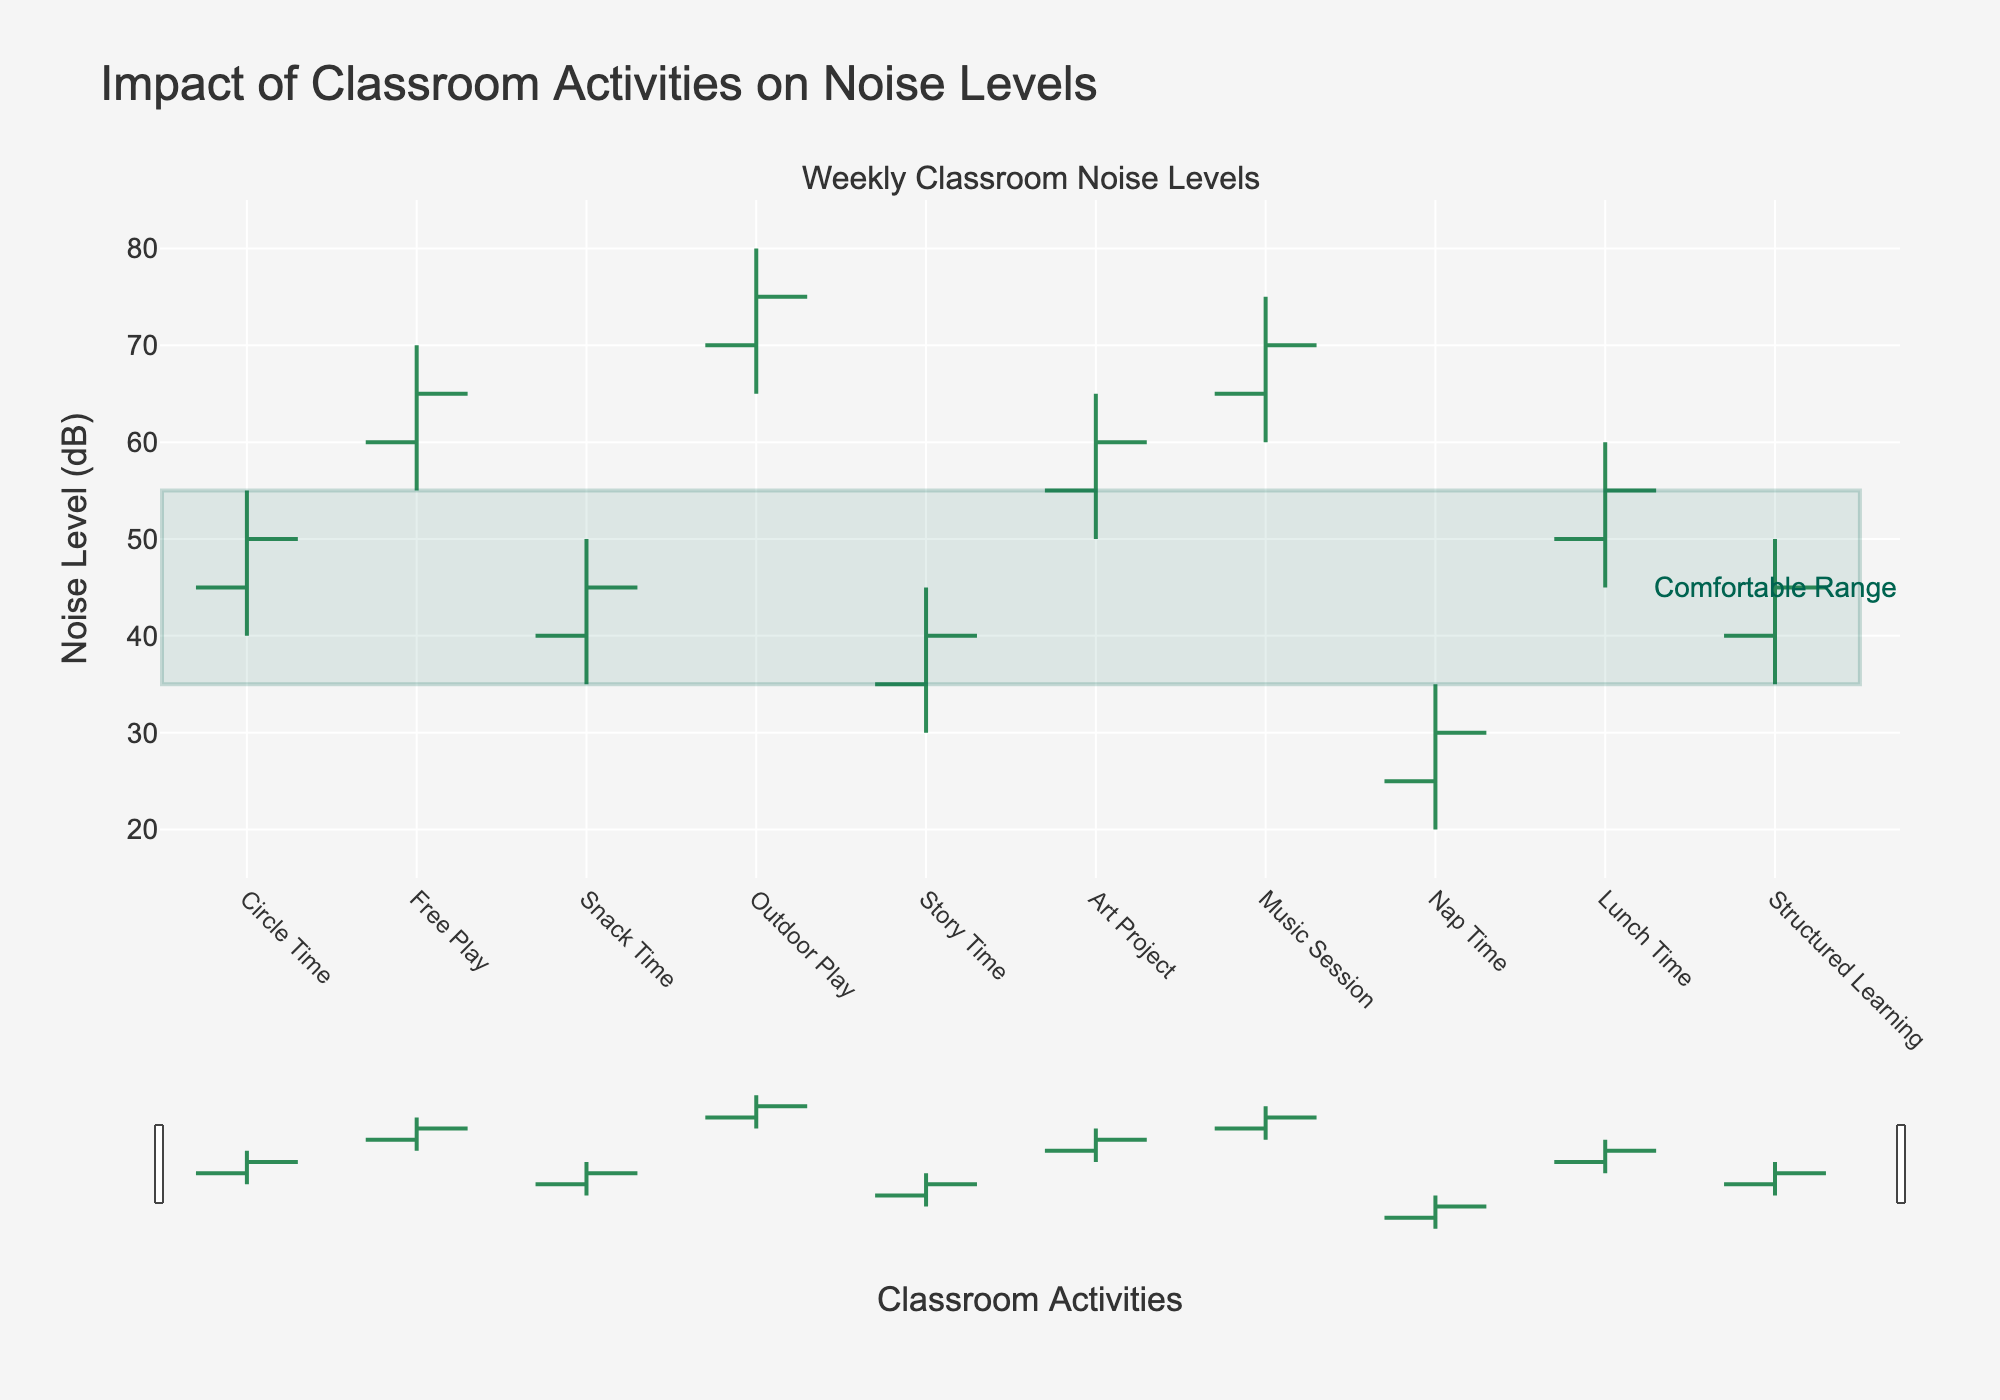What's the range of noise levels during Nap Time? The range is the difference between the highest and lowest values. For Nap Time, the highest noise level is 35 dB and the lowest is 20 dB. So, the range is 35 - 20 = 15 dB.
Answer: 15 dB Which activity has the highest closing noise level? The closing noise level is represented by the 'Close' value. For each activity, compare the closing values. Outdoor Play has the highest closing noise level of 75 dB.
Answer: Outdoor Play How often is the noise level above the comfortable range during Free Play? The comfortable noise range is highlighted between 35 dB and 55 dB. During Free Play, the noise levels (55 dB to 70 dB) are always above this range.
Answer: Always What is the average closing noise level of Story Time and Snack Time combined? The closing noise levels for Story Time and Snack Time are 40 dB and 45 dB respectively. The average is calculated as (40 + 45) / 2 = 42.5 dB.
Answer: 42.5 dB Which activity has the narrowest range of noise levels? The range is calculated by subtracting the lowest value from the highest. For each activity: Circle Time (15), Free Play (15), Snack Time (15), Outdoor Play (15), Story Time (15), Art Project (15), Music Session (15), Nap Time (15), Lunch Time (15), Structured Learning (15). All activities have the same range.
Answer: All activities have the same range How does structured learning's maximum noise level compare to the comfortable range? Structured Learning has a maximum noise level of 50 dB, which is within the comfortable range of 35-55 dB.
Answer: Within range Which activities have both their open and close noise levels within the comfortable range? Circle Time (45-50), Snack Time (40-45), Story Time (35-40), Structured Learning (40-45). All open and close values for these activities fall within the 35-55 dB range.
Answer: Circle Time, Snack Time, Story Time, Structured Learning Which activity shows the greatest increase in noise level from opening to closing? Subtract the open value from the close value for each activity, and find the maximum: Circle Time (50-45=5), Free Play (65-60=5), Snack Time (45-40=5), Outdoor Play (75-70=5), Story Time (40-35=5), Art Project (60-55=5), Music Session (70-65=5), Nap Time (30-25=5), Lunch Time (55-50=5), Structured Learning (45-40=5). All show the same increase.
Answer: All activities show the same increase During which activities is the maximum noise level greater than twice the minimum noise level? Compare twice the minimum value to the maximum value for each activity. If the maximum is greater, it qualifies: Circle Time (55 > 2x40), Free Play (70 > 2x55), Snack Time (50 > 2x35), Outdoor Play (80 > 2x65), Story Time (45 > 2x30), Art Project (65 > 2x50), Music Session (75 > 2x60), Nap Time (35 > 2x20), Lunch Time (60 > 2x45), Structured Learning (50 > 2x35). Only Nap Time does not qualify.
Answer: Circle Time, Free Play, Snack Time, Outdoor Play, Story Time, Art Project, Music Session, Lunch Time, Structured Learning How much higher is the peak noise level during Music Session compared to Circle Time? In Music Session, the peak noise level is 75 dB, and in Circle Time, it is 55 dB. The difference is 75 - 55 = 20 dB.
Answer: 20 dB 